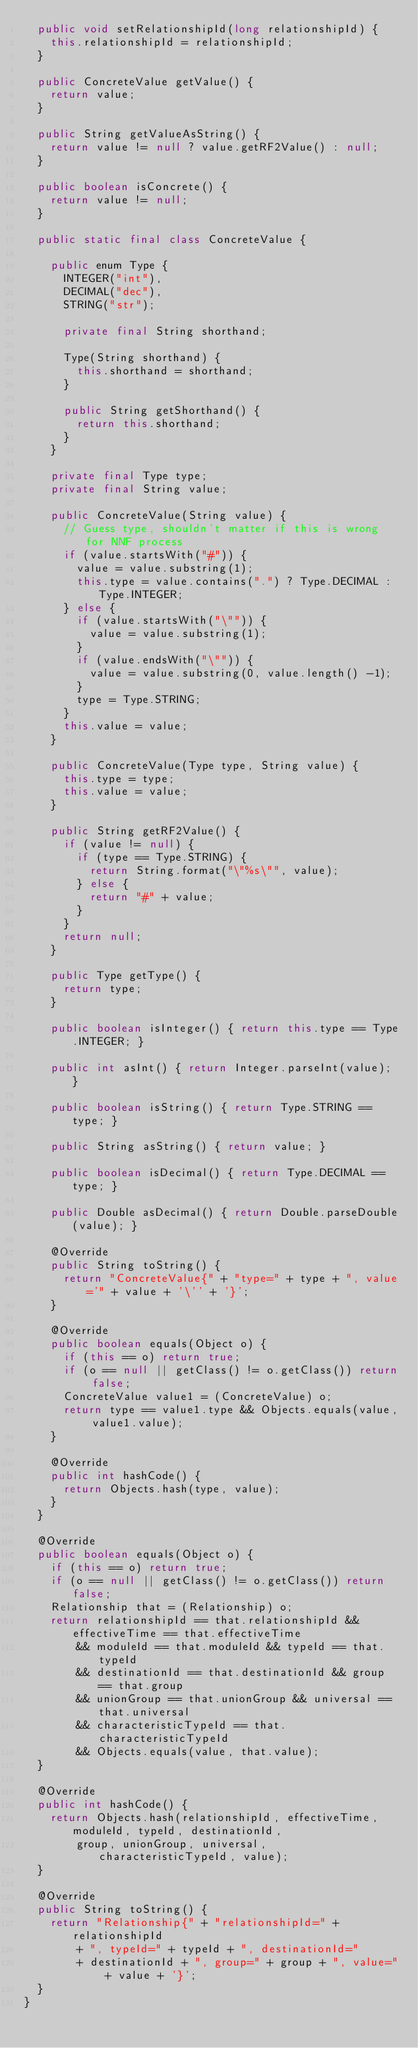<code> <loc_0><loc_0><loc_500><loc_500><_Java_>	public void setRelationshipId(long relationshipId) {
		this.relationshipId = relationshipId;
	}

	public ConcreteValue getValue() {
		return value;
	}

	public String getValueAsString() {
		return value != null ? value.getRF2Value() : null;
	}

	public boolean isConcrete() {
		return value != null;
	}

	public static final class ConcreteValue {

		public enum Type {
			INTEGER("int"),
			DECIMAL("dec"),
			STRING("str");

			private final String shorthand;

			Type(String shorthand) {
				this.shorthand = shorthand;
			}

			public String getShorthand() {
				return this.shorthand;
			}
		}

		private final Type type;
		private final String value;

		public ConcreteValue(String value) {
			// Guess type, shouldn't matter if this is wrong for NNF process
			if (value.startsWith("#")) {
				value = value.substring(1);
				this.type = value.contains(".") ? Type.DECIMAL : Type.INTEGER;
			} else {
				if (value.startsWith("\"")) {
					value = value.substring(1);
				}
				if (value.endsWith("\"")) {
					value = value.substring(0, value.length() -1);
				}
				type = Type.STRING;
			}
			this.value = value;
		}

		public ConcreteValue(Type type, String value) {
			this.type = type;
			this.value = value;
		}

		public String getRF2Value() {
			if (value != null) {
				if (type == Type.STRING) {
					return String.format("\"%s\"", value);
				} else {
					return "#" + value;
				}
			}
			return null;
		}

		public Type getType() {
			return type;
		}

		public boolean isInteger() { return this.type == Type.INTEGER; }

		public int asInt() { return Integer.parseInt(value); }
		
		public boolean isString() { return Type.STRING == type; }
		
		public String asString() { return value; }

		public boolean isDecimal() { return Type.DECIMAL == type; }
		
		public Double asDecimal() { return Double.parseDouble(value); }

		@Override
		public String toString() {
			return "ConcreteValue{" + "type=" + type + ", value='" + value + '\'' + '}';
		}

		@Override
		public boolean equals(Object o) {
			if (this == o) return true;
			if (o == null || getClass() != o.getClass()) return false;
			ConcreteValue value1 = (ConcreteValue) o;
			return type == value1.type && Objects.equals(value, value1.value);
		}

		@Override
		public int hashCode() {
			return Objects.hash(type, value);
		}
	}

	@Override
	public boolean equals(Object o) {
		if (this == o) return true;
		if (o == null || getClass() != o.getClass()) return false;
		Relationship that = (Relationship) o;
		return relationshipId == that.relationshipId && effectiveTime == that.effectiveTime
				&& moduleId == that.moduleId && typeId == that.typeId
				&& destinationId == that.destinationId && group == that.group
				&& unionGroup == that.unionGroup && universal == that.universal
				&& characteristicTypeId == that.characteristicTypeId
				&& Objects.equals(value, that.value);
	}

	@Override
	public int hashCode() {
		return Objects.hash(relationshipId, effectiveTime, moduleId, typeId, destinationId,
				group, unionGroup, universal, characteristicTypeId, value);
	}

	@Override
	public String toString() {
		return "Relationship{" + "relationshipId=" + relationshipId
				+ ", typeId=" + typeId + ", destinationId="
				+ destinationId + ", group=" + group + ", value=" + value + '}';
	}
}
</code> 